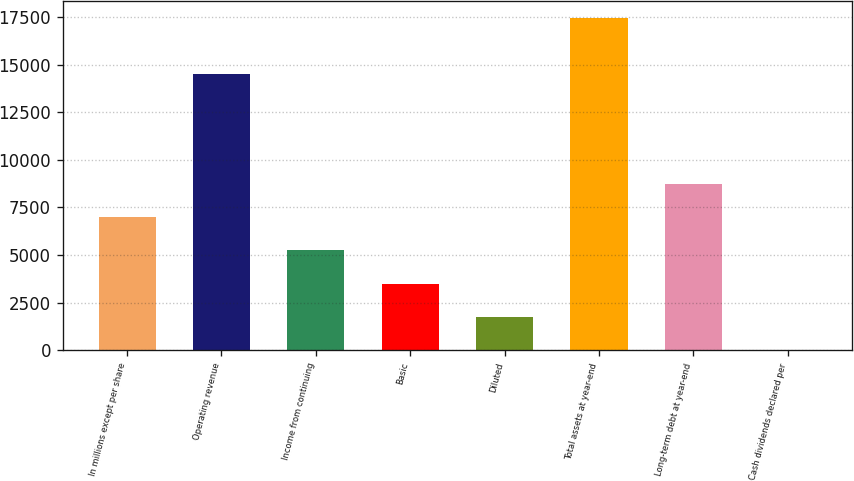<chart> <loc_0><loc_0><loc_500><loc_500><bar_chart><fcel>In millions except per share<fcel>Operating revenue<fcel>Income from continuing<fcel>Basic<fcel>Diluted<fcel>Total assets at year-end<fcel>Long-term debt at year-end<fcel>Cash dividends declared per<nl><fcel>6987.09<fcel>14484<fcel>5240.77<fcel>3494.45<fcel>1748.13<fcel>17465<fcel>8733.41<fcel>1.81<nl></chart> 